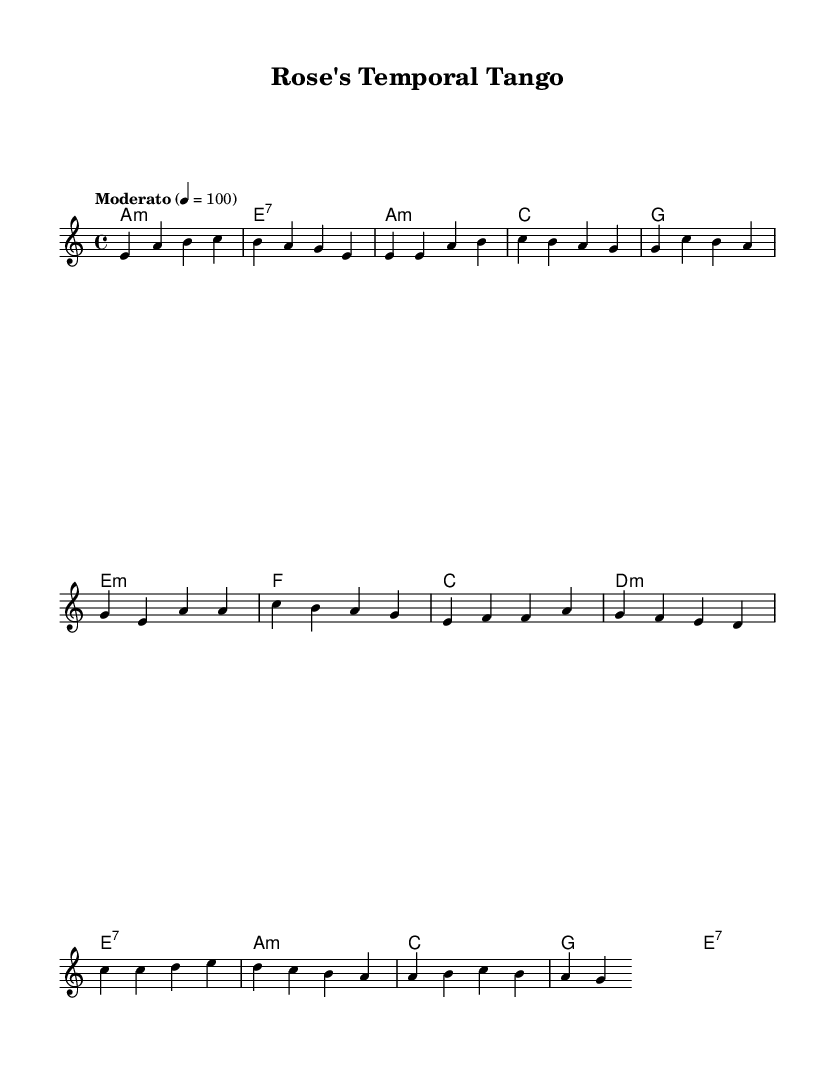What is the key signature of this music? The key signature shows a minor with no sharps or flats, which corresponds to A minor.
Answer: A minor What is the time signature of the piece? The time signature appears at the beginning of the score, showing a 4 on top of a 4 at the beginning, indicating four beats per measure.
Answer: 4/4 What is the tempo marking for this score? The tempo marking indicates "Moderato," which specifies a moderate pace. The metronome marking (4 = 100) further confirms this by showing a specific beats per minute rate.
Answer: Moderato How many measures are in the Chorus section? By counting the measures designated in the Chorus, consisting of the lines explicitly labeled as "Chorus" and counting the corresponding measures, there are a total of four measures.
Answer: 4 What is the first chord of the Intro section? The first chord is labeled as "a:m," signifying an A minor chord, which you can directly see at the beginning of the Intro section.
Answer: A minor Which section includes a crescendo in intensity? The Bridge section typically includes a build-up in intensity leading to the peak of the song, often characterized by a rising melodic line and higher dynamics than the previous sections.
Answer: Bridge What type of harmony is used in the Chorus? The harmony in the Chorus uses triadic chords, showing a mix of major and minor chords typical for ballads, and can be identified in the chord changes indicated in this section.
Answer: Triadic 